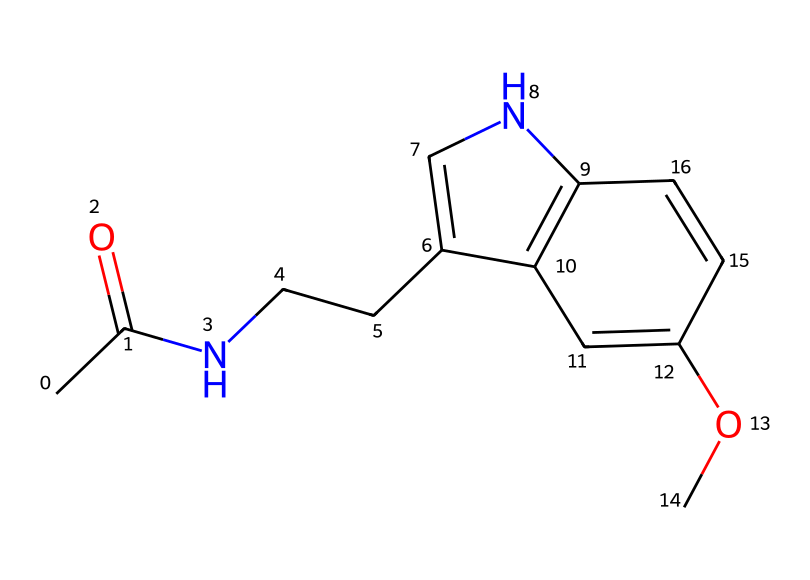what is the molecular formula of the compound? To determine the molecular formula from the SMILES representation, count the number of each type of atom present. In the given SMILES, there are 11 carbon (C) atoms, 13 hydrogen (H) atoms, 2 nitrogen (N) atoms, and 1 oxygen (O) atom. Therefore, the molecular formula is C11H13N2O.
Answer: C11H13N2O how many rings are present in the structure? By analyzing the SMILES representation, we notice cyclic structures indicated by the presence of numbers that connect atoms. There are two instances of numbers ('1' and '2'), which denote two rings in the structure. Thus, the total number of rings is 2.
Answer: 2 what functional groups are present in the compound? Functional groups can be determined by identifying specific groups of atoms within the molecular structure that exhibit characteristic chemical reactions. The structure contains an amine group (due to the nitrogen atoms), an ether group (noted by the 'OC'), and a carbonyl group (from the '=O' attached to the carbon). Thus, the main functional groups identified are amine, ether, and carbonyl.
Answer: amine, ether, carbonyl how does this compound act in the brain? The compound is melatonin, which primarily regulates sleep and circadian rhythms by binding to melatonin receptors in the brain. Its structure, particularly the presence of nitrogen, allows it to interact effectively with these receptors, facilitating sleep promotion and modulation of biological rhythms.
Answer: regulates sleep is this compound a coordination compound? Coordination compounds typically involve a central metal atom bonded to surrounding ligands. In this SMILES, there are no metal atoms or typical ligand structures; instead, it is a small organic molecule (melatonin). Hence, it is not a coordination compound.
Answer: no 